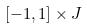<formula> <loc_0><loc_0><loc_500><loc_500>[ - 1 , 1 ] \times J</formula> 